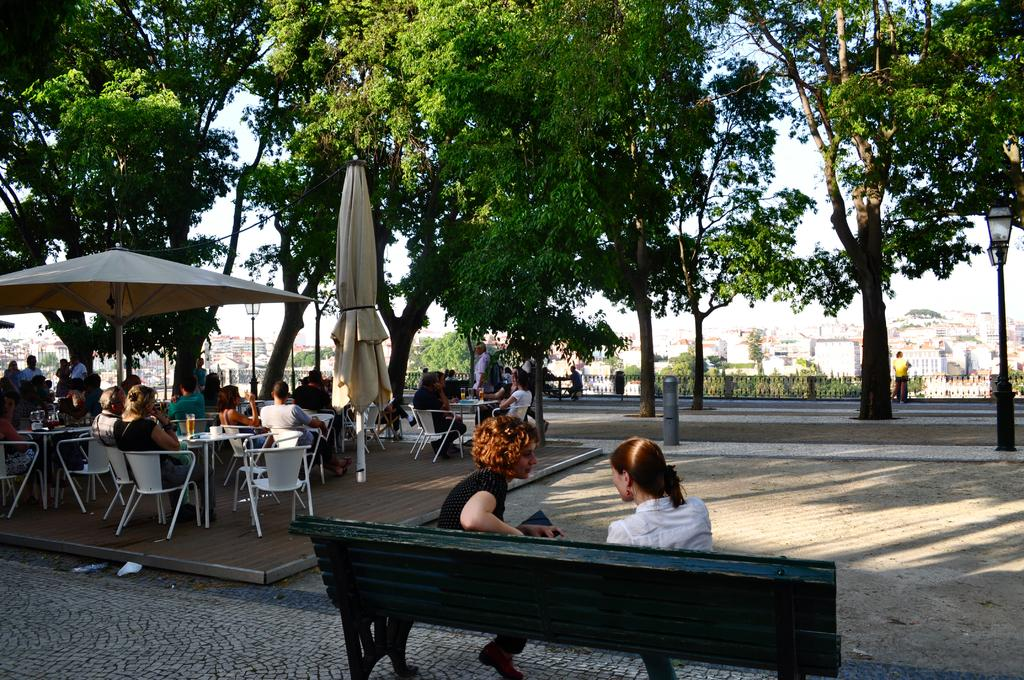What type of vegetation can be seen in the image? There are trees in the image. What are the people in the image doing? The people in the image are seated on chairs and a bench. What object is present to provide shade in the image? There is an umbrella visible in the image. Can you see any yokes in the image? There is no yoke present in the image. What type of fang can be seen in the image? There are no fangs present in the image. 